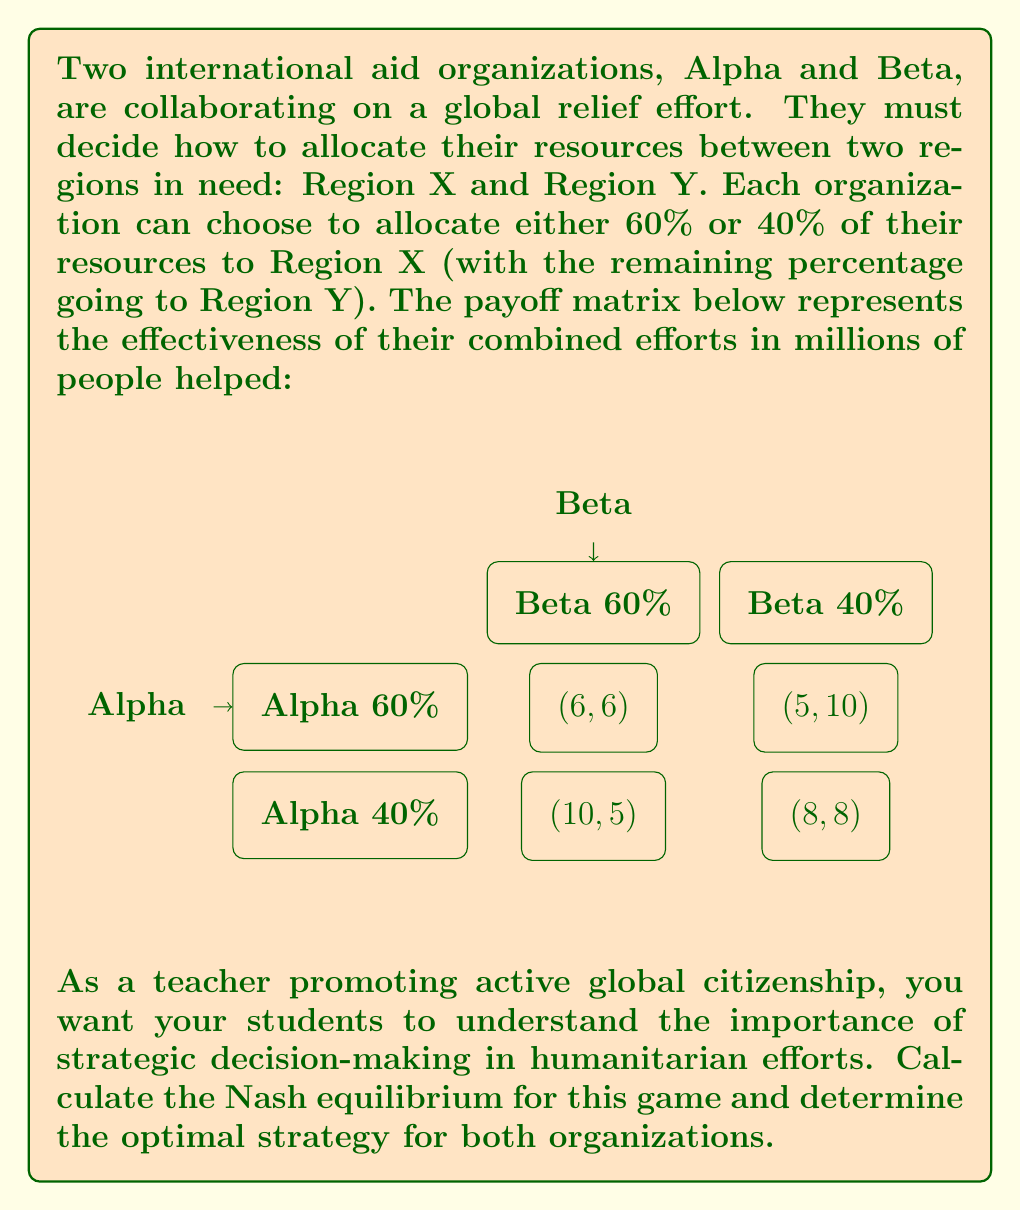Provide a solution to this math problem. To find the Nash equilibrium, we need to identify the strategy pairs where neither player has an incentive to unilaterally change their strategy.

Step 1: Analyze Alpha's best responses
- If Beta chooses 60%:
  Alpha's payoff for 60%: 6
  Alpha's payoff for 40%: 5
  Best response: 60%
- If Beta chooses 40%:
  Alpha's payoff for 60%: 10
  Alpha's payoff for 40%: 8
  Best response: 60%

Step 2: Analyze Beta's best responses
- If Alpha chooses 60%:
  Beta's payoff for 60%: 6
  Beta's payoff for 40%: 5
  Best response: 60%
- If Alpha chooses 40%:
  Beta's payoff for 60%: 10
  Beta's payoff for 40%: 8
  Best response: 60%

Step 3: Identify the Nash equilibrium
The Nash equilibrium occurs when both organizations choose their best response to the other's strategy. In this case, both Alpha and Beta have a dominant strategy of allocating 60% to Region X, regardless of what the other organization does.

Therefore, the Nash equilibrium is (60%, 60%), resulting in a payoff of (6, 6) million people helped.

This solution demonstrates that even though a different strategy pair (40%, 40%) would result in a higher total payoff of (8, 8) million people helped, the individual incentives lead to a suboptimal outcome. This illustrates the concept of the "Prisoner's Dilemma" in game theory, which is relevant to many real-world scenarios in global cooperation and resource allocation.
Answer: Nash equilibrium: (60%, 60%), payoff: (6, 6) million people helped 